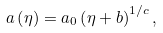<formula> <loc_0><loc_0><loc_500><loc_500>a \left ( \eta \right ) = a _ { 0 } \left ( \eta + b \right ) ^ { 1 / c } ,</formula> 